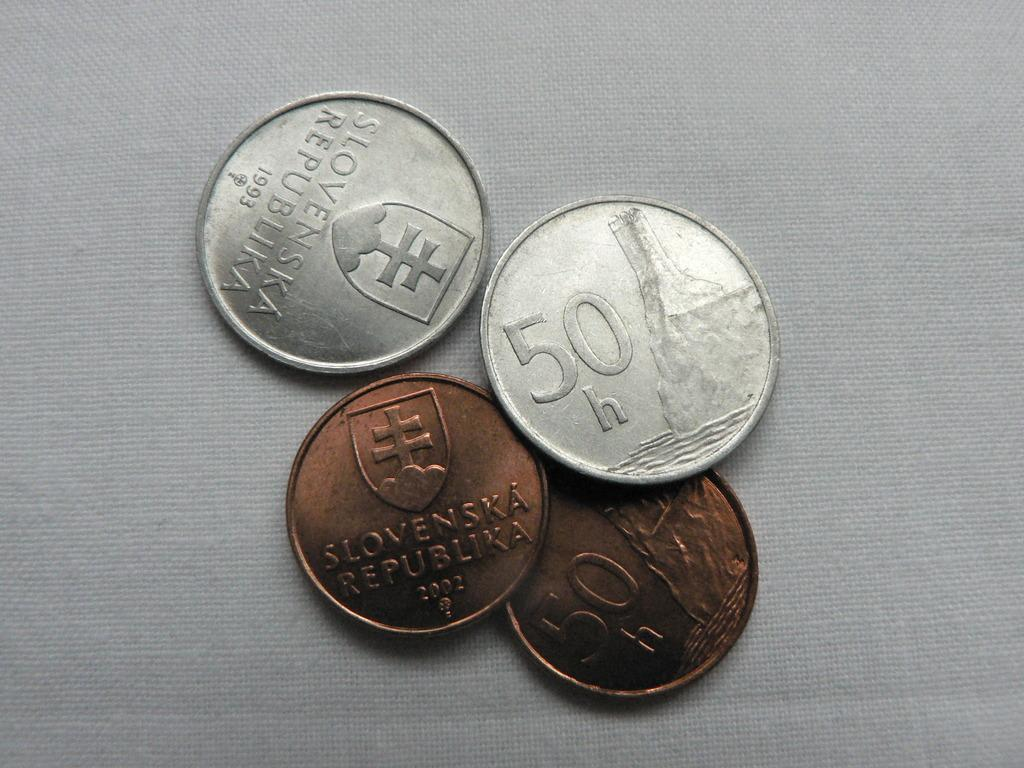<image>
Share a concise interpretation of the image provided. A grouping of four coins with the denomination 50 on two of them. 